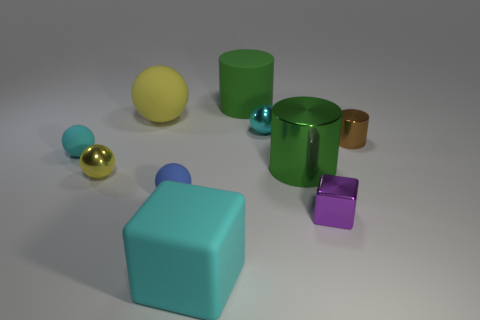Subtract all cyan balls. How many balls are left? 3 Subtract all cyan shiny balls. How many balls are left? 4 Subtract 0 blue cubes. How many objects are left? 10 Subtract all cubes. How many objects are left? 8 Subtract 5 balls. How many balls are left? 0 Subtract all purple blocks. Subtract all gray cylinders. How many blocks are left? 1 Subtract all purple cubes. How many gray balls are left? 0 Subtract all large metallic cylinders. Subtract all cyan matte balls. How many objects are left? 8 Add 4 tiny yellow metal balls. How many tiny yellow metal balls are left? 5 Add 2 tiny brown rubber cylinders. How many tiny brown rubber cylinders exist? 2 